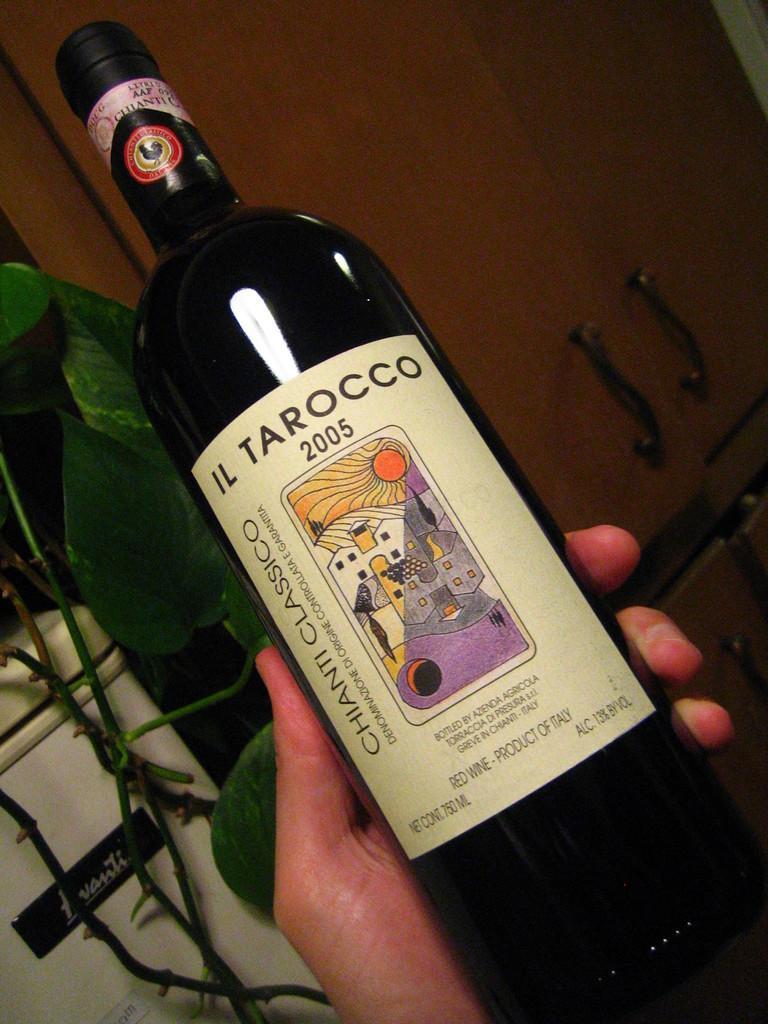In one or two sentences, can you explain what this image depicts? At the bottom of this image I can see a person's hand holding a bottle. In the background there is a door and a plant. In the bottom left there is a white color box which seems to be a machine. 